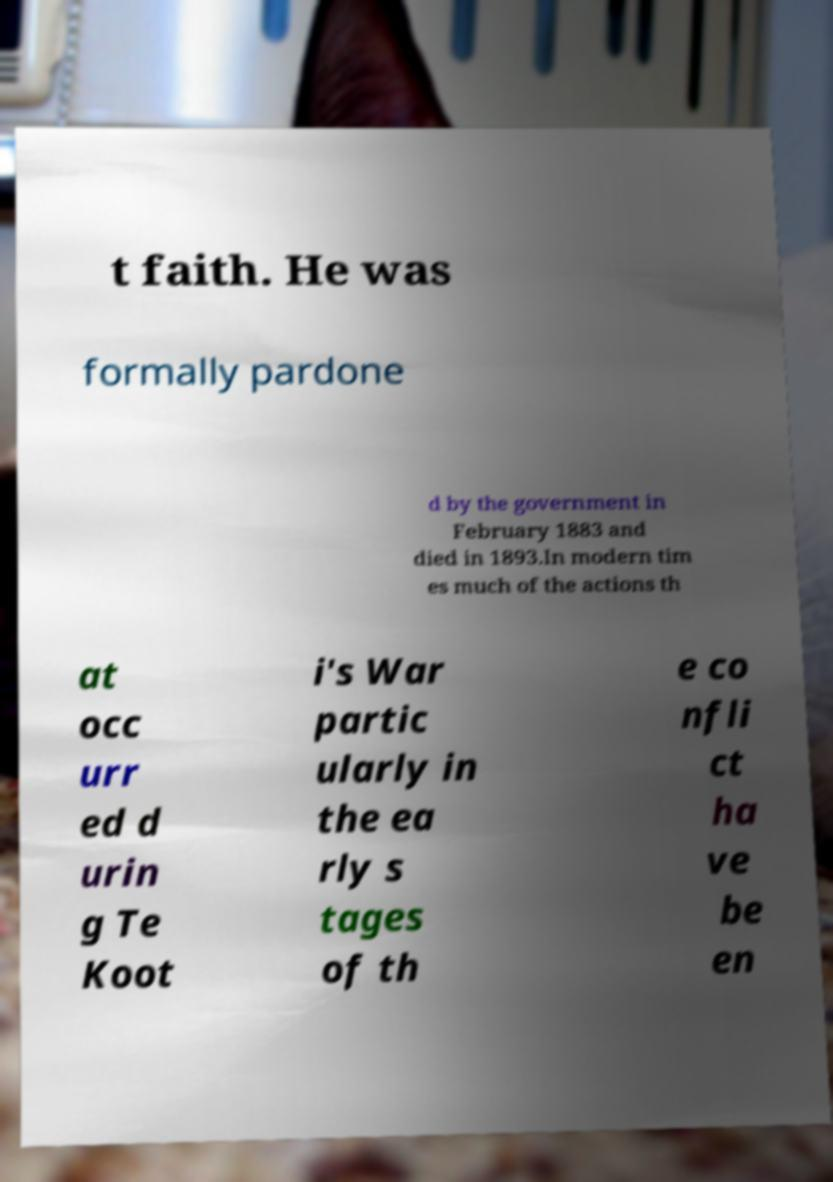There's text embedded in this image that I need extracted. Can you transcribe it verbatim? t faith. He was formally pardone d by the government in February 1883 and died in 1893.In modern tim es much of the actions th at occ urr ed d urin g Te Koot i's War partic ularly in the ea rly s tages of th e co nfli ct ha ve be en 